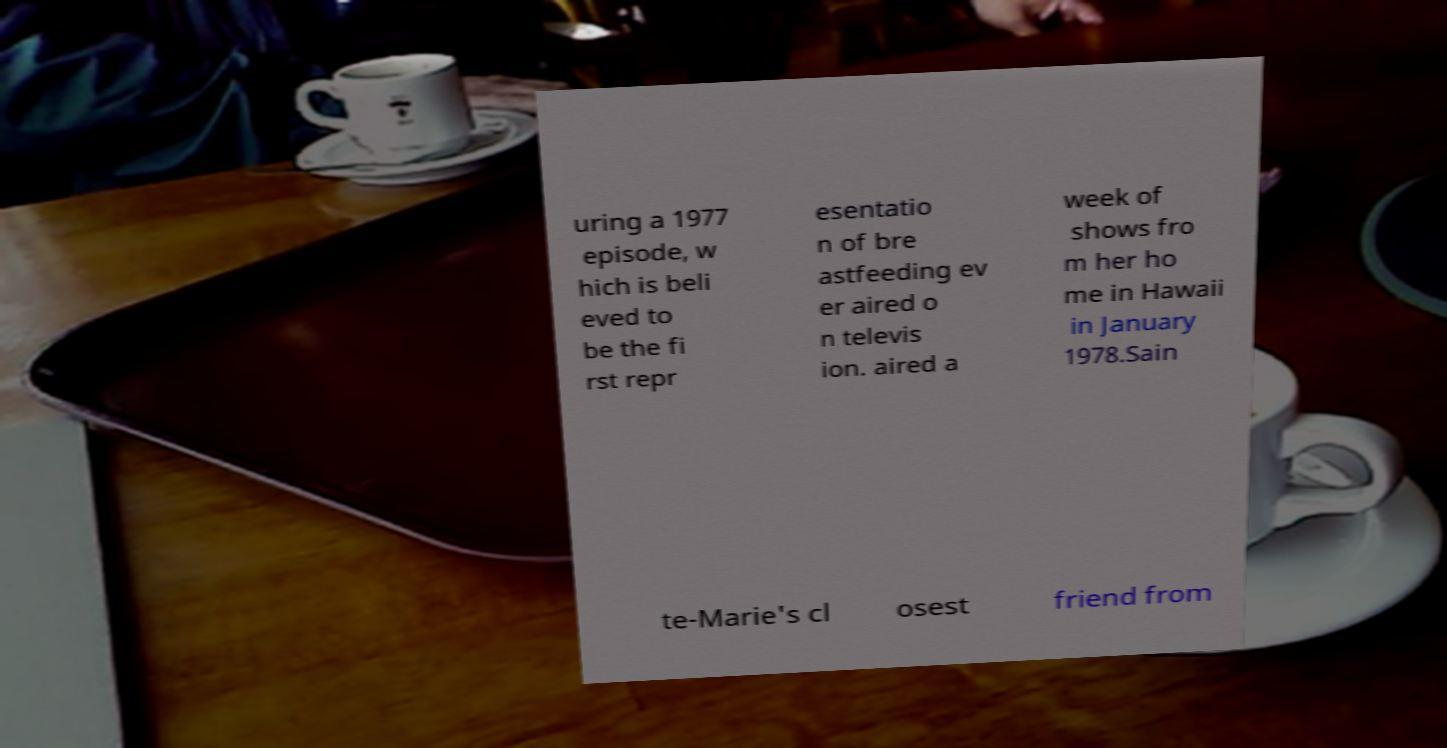What messages or text are displayed in this image? I need them in a readable, typed format. uring a 1977 episode, w hich is beli eved to be the fi rst repr esentatio n of bre astfeeding ev er aired o n televis ion. aired a week of shows fro m her ho me in Hawaii in January 1978.Sain te-Marie's cl osest friend from 